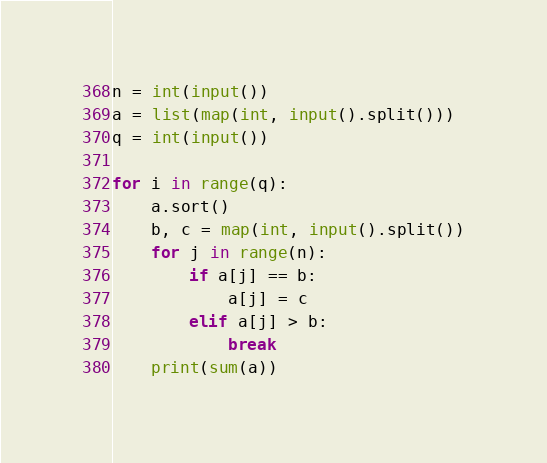Convert code to text. <code><loc_0><loc_0><loc_500><loc_500><_Python_>n = int(input())
a = list(map(int, input().split()))
q = int(input())

for i in range(q):
    a.sort()
    b, c = map(int, input().split())
    for j in range(n):
        if a[j] == b:
            a[j] = c
        elif a[j] > b:
            break
    print(sum(a))</code> 